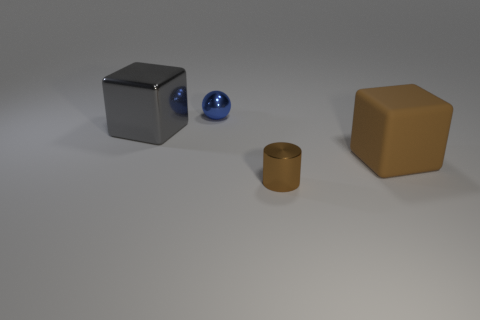What size is the cube that is to the right of the big thing that is left of the small blue shiny ball?
Offer a very short reply. Large. What number of other things are the same color as the sphere?
Provide a short and direct response. 0. What material is the tiny brown cylinder?
Provide a short and direct response. Metal. Are there any tiny purple shiny balls?
Provide a succinct answer. No. Is the number of tiny blue spheres that are on the right side of the tiny blue metallic object the same as the number of brown cubes?
Make the answer very short. No. Are there any other things that have the same material as the large brown block?
Your response must be concise. No. How many big objects are either gray metal objects or red matte cylinders?
Offer a terse response. 1. What shape is the large object that is the same color as the metal cylinder?
Ensure brevity in your answer.  Cube. Is the tiny thing that is behind the tiny brown thing made of the same material as the large brown object?
Give a very brief answer. No. What is the material of the big block that is in front of the large block that is to the left of the big brown cube?
Your answer should be compact. Rubber. 